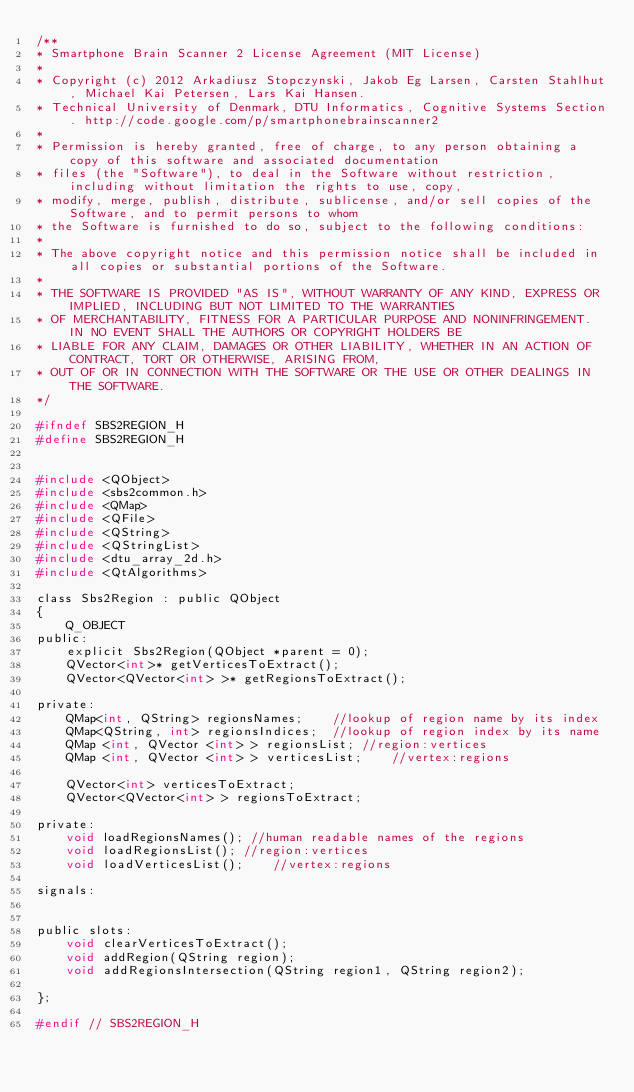<code> <loc_0><loc_0><loc_500><loc_500><_C_>/**
* Smartphone Brain Scanner 2 License Agreement (MIT License)
*
* Copyright (c) 2012 Arkadiusz Stopczynski, Jakob Eg Larsen, Carsten Stahlhut, Michael Kai Petersen, Lars Kai Hansen.
* Technical University of Denmark, DTU Informatics, Cognitive Systems Section. http://code.google.com/p/smartphonebrainscanner2
*
* Permission is hereby granted, free of charge, to any person obtaining a copy of this software and associated documentation
* files (the "Software"), to deal in the Software without restriction, including without limitation the rights to use, copy,
* modify, merge, publish, distribute, sublicense, and/or sell copies of the Software, and to permit persons to whom
* the Software is furnished to do so, subject to the following conditions:
*
* The above copyright notice and this permission notice shall be included in all copies or substantial portions of the Software.
*
* THE SOFTWARE IS PROVIDED "AS IS", WITHOUT WARRANTY OF ANY KIND, EXPRESS OR IMPLIED, INCLUDING BUT NOT LIMITED TO THE WARRANTIES
* OF MERCHANTABILITY, FITNESS FOR A PARTICULAR PURPOSE AND NONINFRINGEMENT. IN NO EVENT SHALL THE AUTHORS OR COPYRIGHT HOLDERS BE
* LIABLE FOR ANY CLAIM, DAMAGES OR OTHER LIABILITY, WHETHER IN AN ACTION OF CONTRACT, TORT OR OTHERWISE, ARISING FROM,
* OUT OF OR IN CONNECTION WITH THE SOFTWARE OR THE USE OR OTHER DEALINGS IN THE SOFTWARE.
*/

#ifndef SBS2REGION_H
#define SBS2REGION_H


#include <QObject>
#include <sbs2common.h>
#include <QMap>
#include <QFile>
#include <QString>
#include <QStringList>
#include <dtu_array_2d.h>
#include <QtAlgorithms>

class Sbs2Region : public QObject
{
    Q_OBJECT
public:
    explicit Sbs2Region(QObject *parent = 0);
    QVector<int>* getVerticesToExtract();
    QVector<QVector<int> >* getRegionsToExtract();

private:
    QMap<int, QString> regionsNames;	//lookup of region name by its index
    QMap<QString, int> regionsIndices;	//lookup of region index by its name
    QMap <int, QVector <int> > regionsList; //region:vertices
    QMap <int, QVector <int> > verticesList;	//vertex:regions

    QVector<int> verticesToExtract;
    QVector<QVector<int> > regionsToExtract;

private:
    void loadRegionsNames(); //human readable names of the regions
    void loadRegionsList(); //region:vertices
    void loadVerticesList();	//vertex:regions

signals:


public slots:
    void clearVerticesToExtract();
    void addRegion(QString region);
    void addRegionsIntersection(QString region1, QString region2);

};

#endif // SBS2REGION_H
</code> 